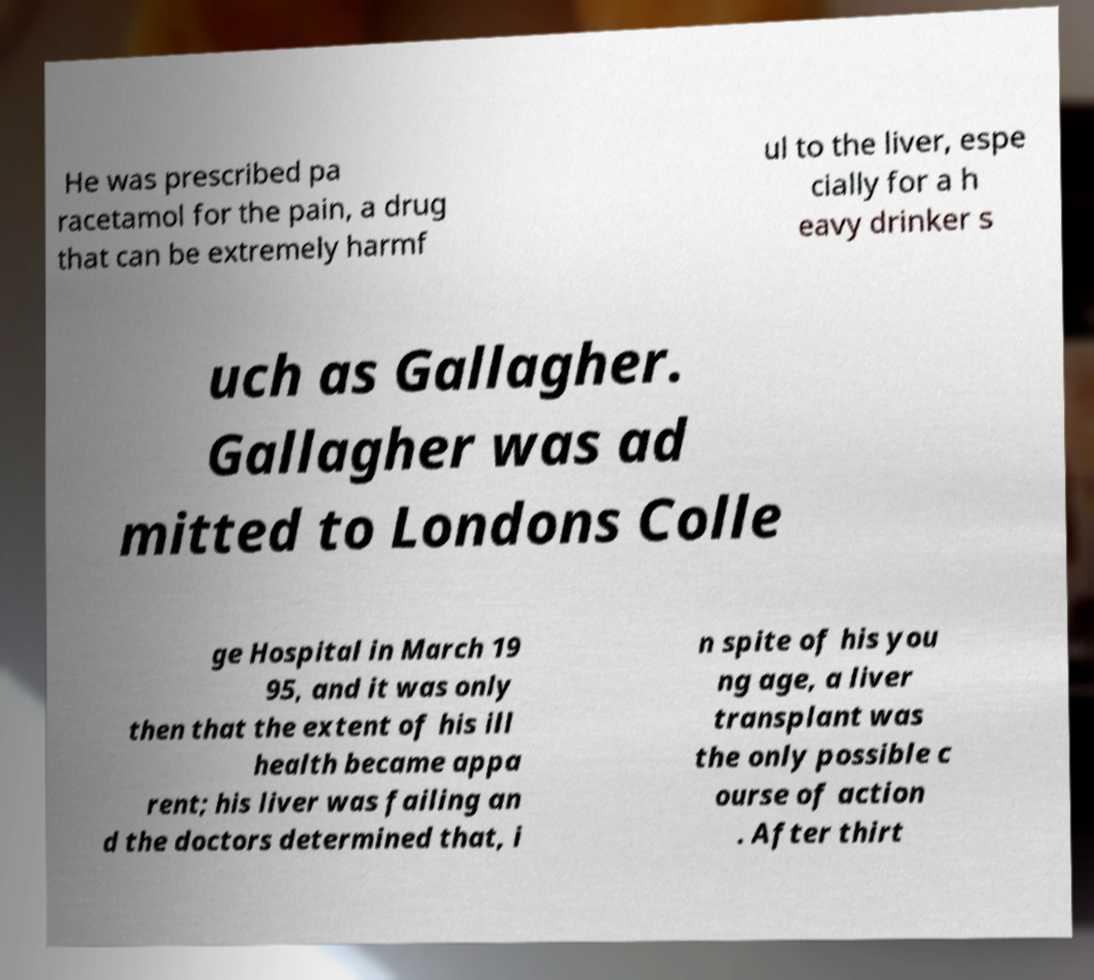Could you assist in decoding the text presented in this image and type it out clearly? He was prescribed pa racetamol for the pain, a drug that can be extremely harmf ul to the liver, espe cially for a h eavy drinker s uch as Gallagher. Gallagher was ad mitted to Londons Colle ge Hospital in March 19 95, and it was only then that the extent of his ill health became appa rent; his liver was failing an d the doctors determined that, i n spite of his you ng age, a liver transplant was the only possible c ourse of action . After thirt 